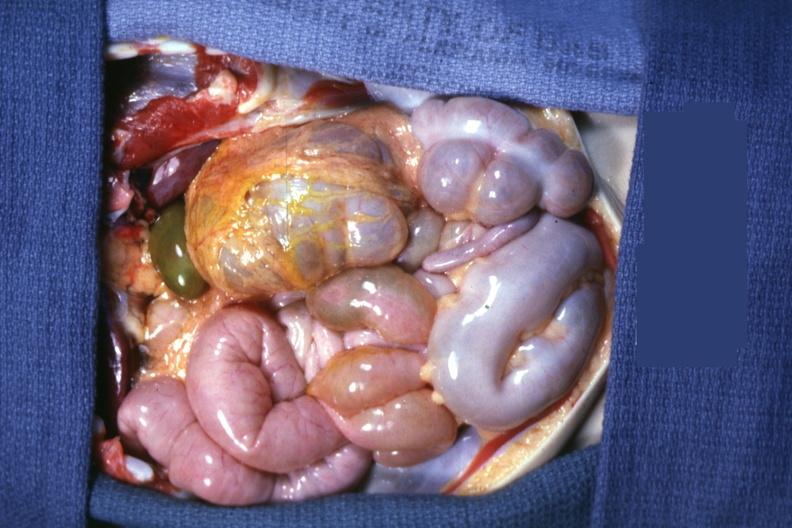s carcinomatosis present?
Answer the question using a single word or phrase. No 